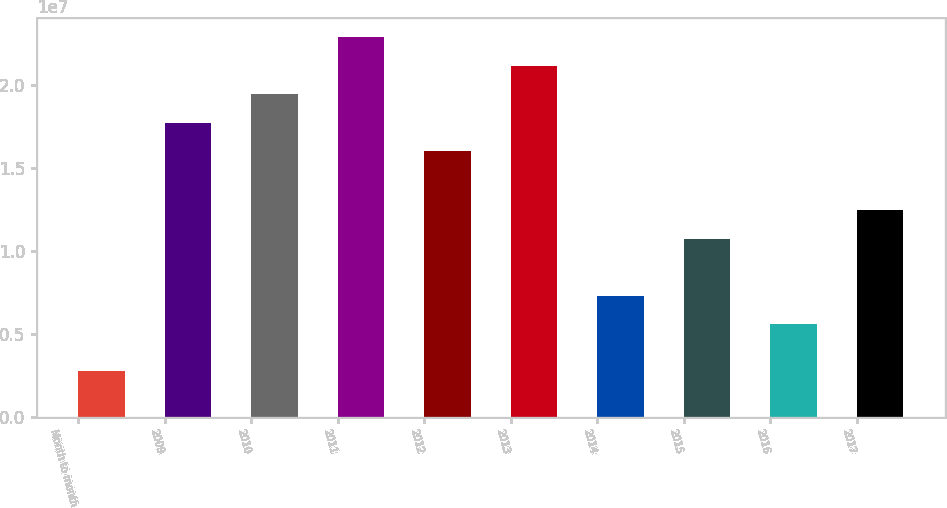<chart> <loc_0><loc_0><loc_500><loc_500><bar_chart><fcel>Month to month<fcel>2009<fcel>2010<fcel>2011<fcel>2012<fcel>2013<fcel>2014<fcel>2015<fcel>2016<fcel>2017<nl><fcel>2.758e+06<fcel>1.77173e+07<fcel>1.94326e+07<fcel>2.28632e+07<fcel>1.6002e+07<fcel>2.11479e+07<fcel>7.3013e+06<fcel>1.07319e+07<fcel>5.586e+06<fcel>1.24472e+07<nl></chart> 